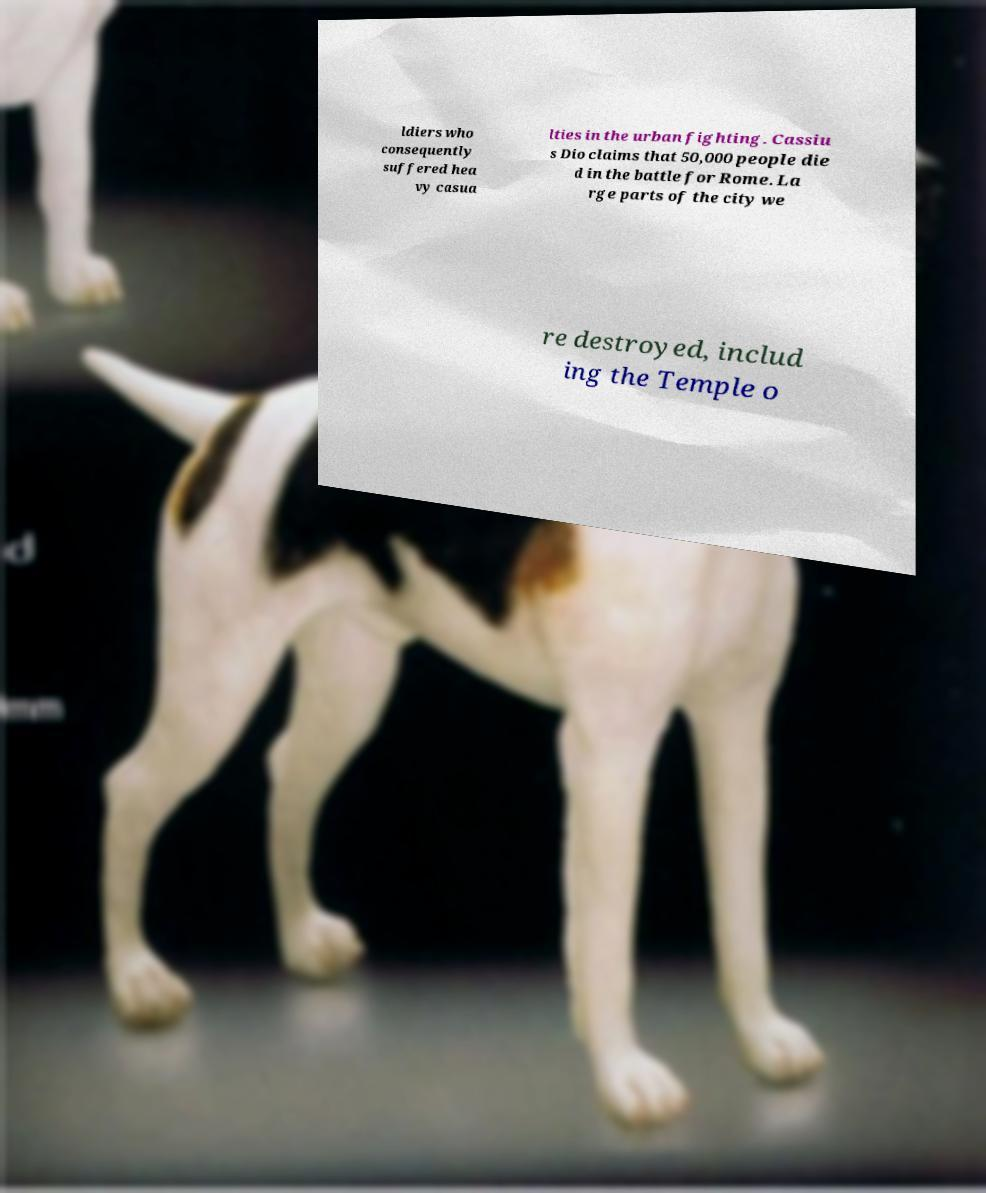Please identify and transcribe the text found in this image. ldiers who consequently suffered hea vy casua lties in the urban fighting. Cassiu s Dio claims that 50,000 people die d in the battle for Rome. La rge parts of the city we re destroyed, includ ing the Temple o 